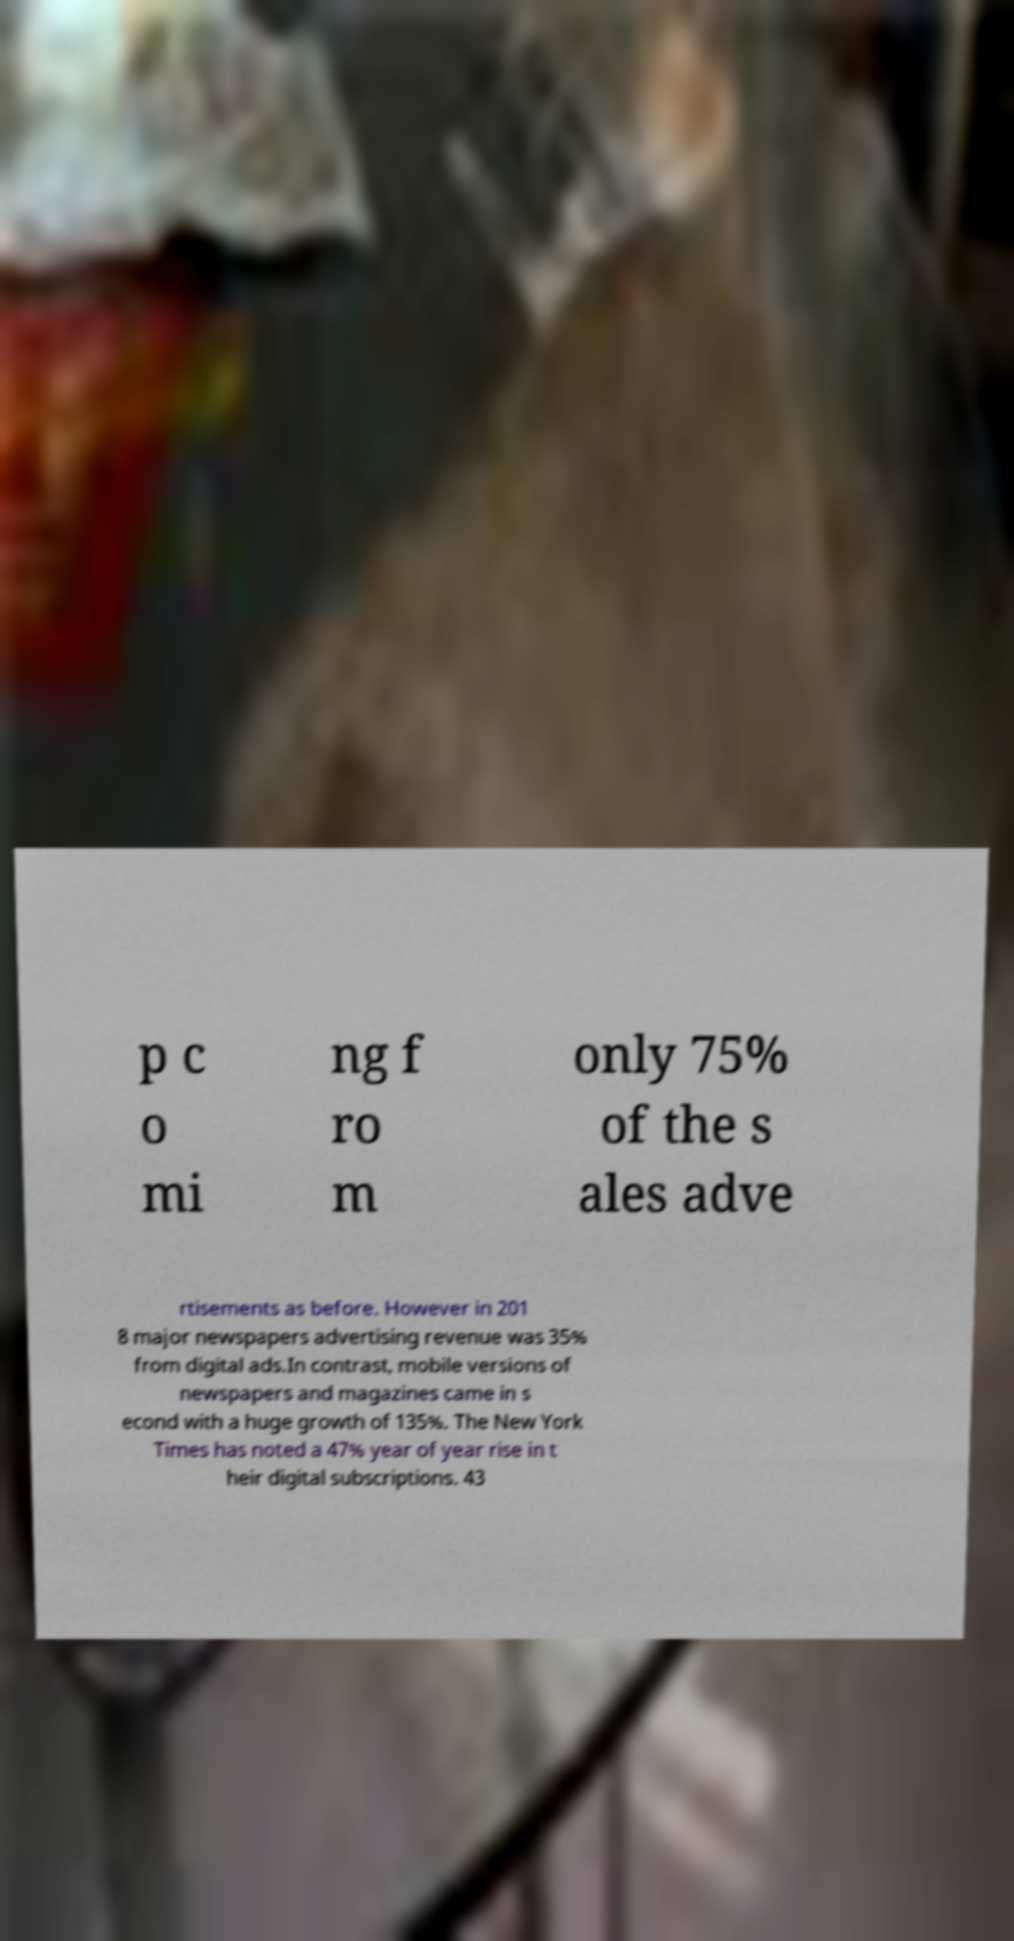For documentation purposes, I need the text within this image transcribed. Could you provide that? p c o mi ng f ro m only 75% of the s ales adve rtisements as before. However in 201 8 major newspapers advertising revenue was 35% from digital ads.In contrast, mobile versions of newspapers and magazines came in s econd with a huge growth of 135%. The New York Times has noted a 47% year of year rise in t heir digital subscriptions. 43 